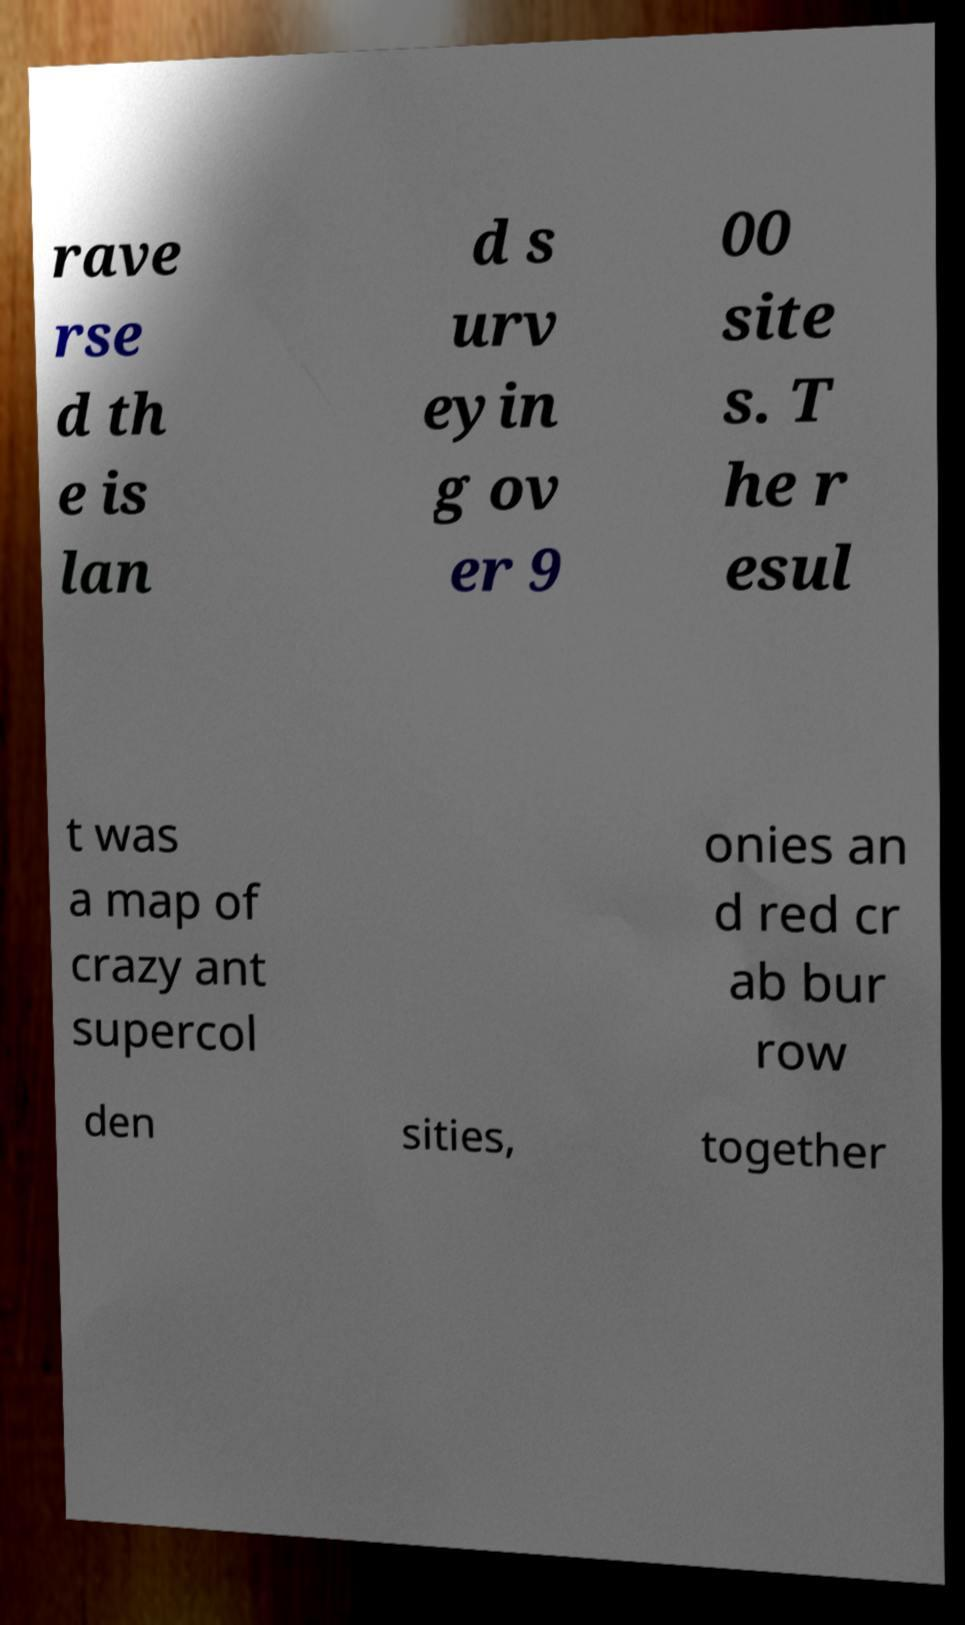Can you read and provide the text displayed in the image?This photo seems to have some interesting text. Can you extract and type it out for me? rave rse d th e is lan d s urv eyin g ov er 9 00 site s. T he r esul t was a map of crazy ant supercol onies an d red cr ab bur row den sities, together 